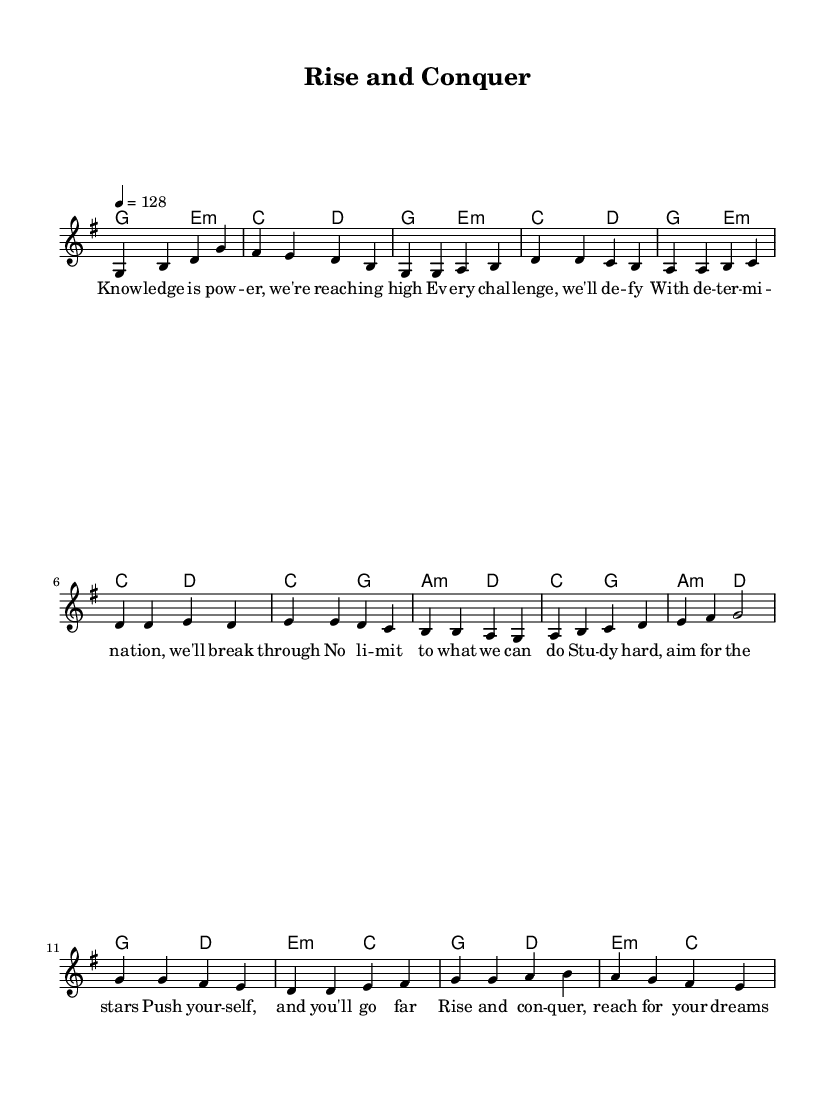What is the key signature of this music? The key signature is G major, which has one sharp (F#).
Answer: G major What is the time signature of this music? The time signature shown is 4/4, indicating four beats per measure.
Answer: 4/4 What is the tempo marking for the piece? The tempo marking indicates a speed of 128 beats per minute.
Answer: 128 How many measures are in the Chorus section? By counting the measures present in the Chorus section, there are 4 measures indicated.
Answer: 4 What is the main theme of the lyrics in the Chorus? The main theme focuses on empowerment and achieving academic success, emphasizing belief in oneself and the future.
Answer: Empowerment In the Pre-Chorus, what is the primary call to action? The Pre-Chorus emphasizes the importance of hard work and aspiration, encouraging listeners to push themselves for success.
Answer: Aim for the stars Which musical style does this anthem represent? The anthem represents the K-Pop genre, characterized by its catchy melodies and motivational lyrics that speak to youth empowerment.
Answer: K-Pop 